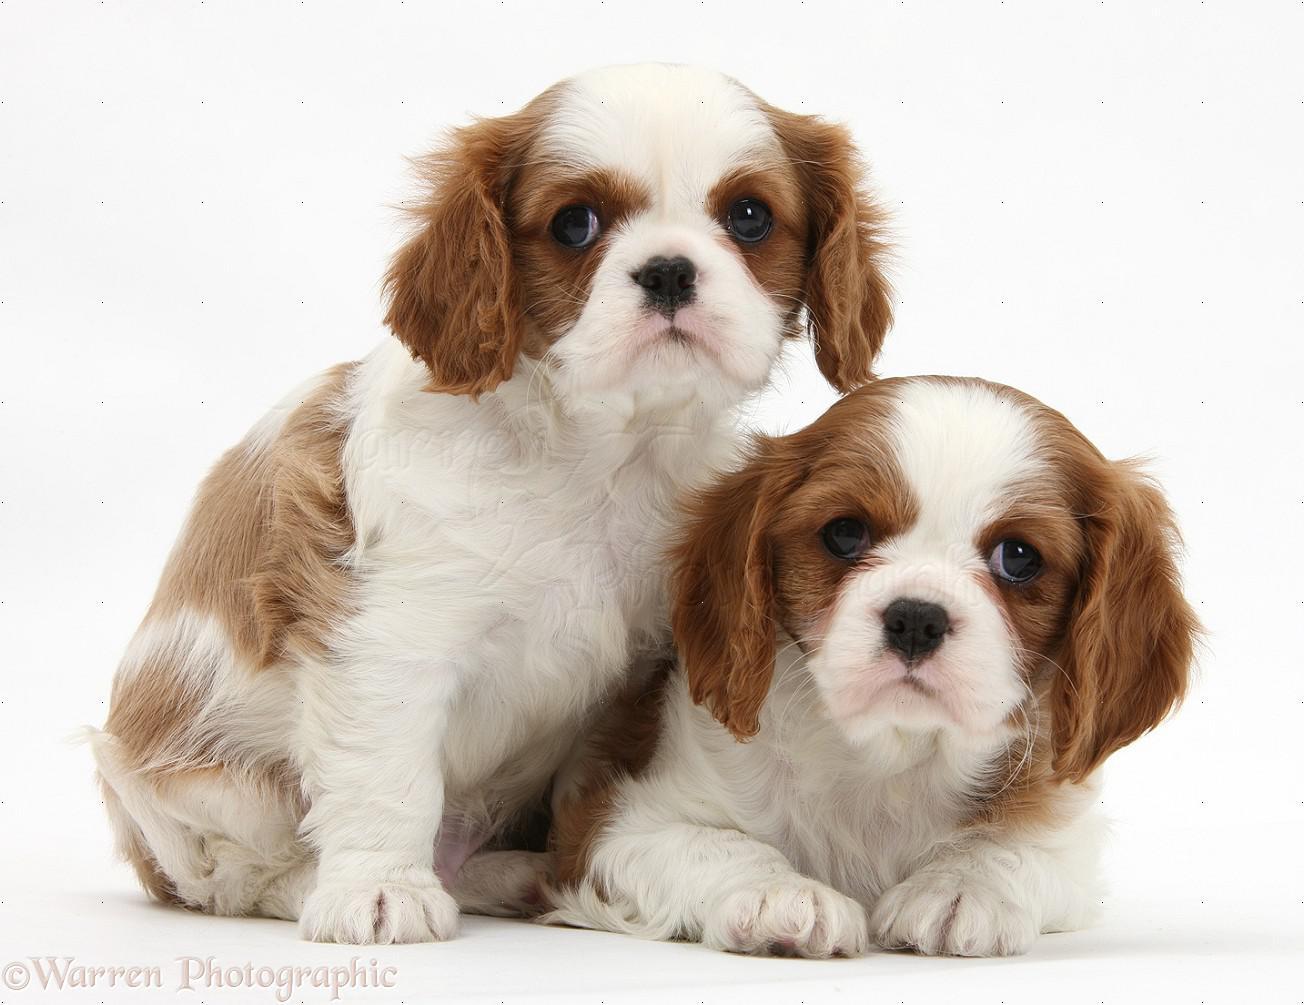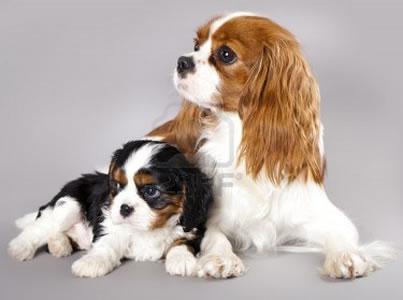The first image is the image on the left, the second image is the image on the right. Evaluate the accuracy of this statement regarding the images: "Each image has one dog.". Is it true? Answer yes or no. No. 